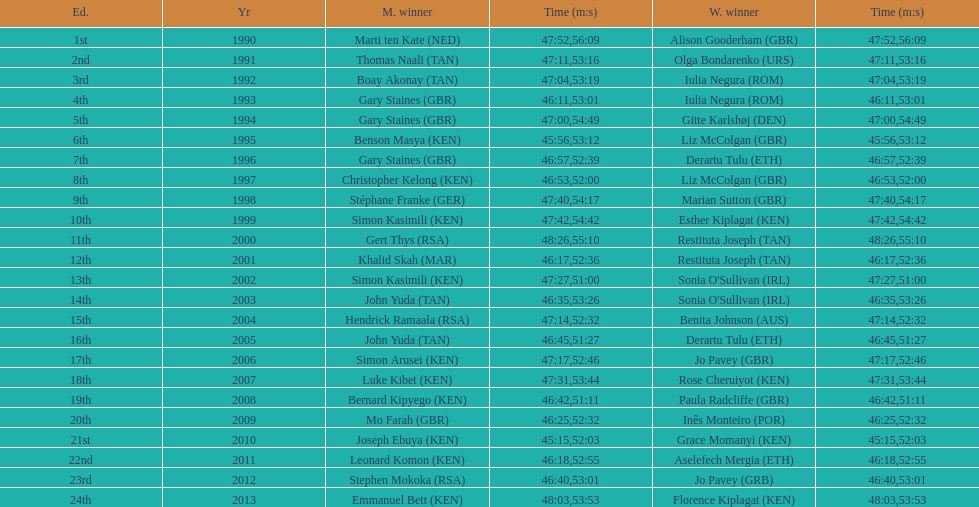How many men winners had times at least 46 minutes or under? 2. 